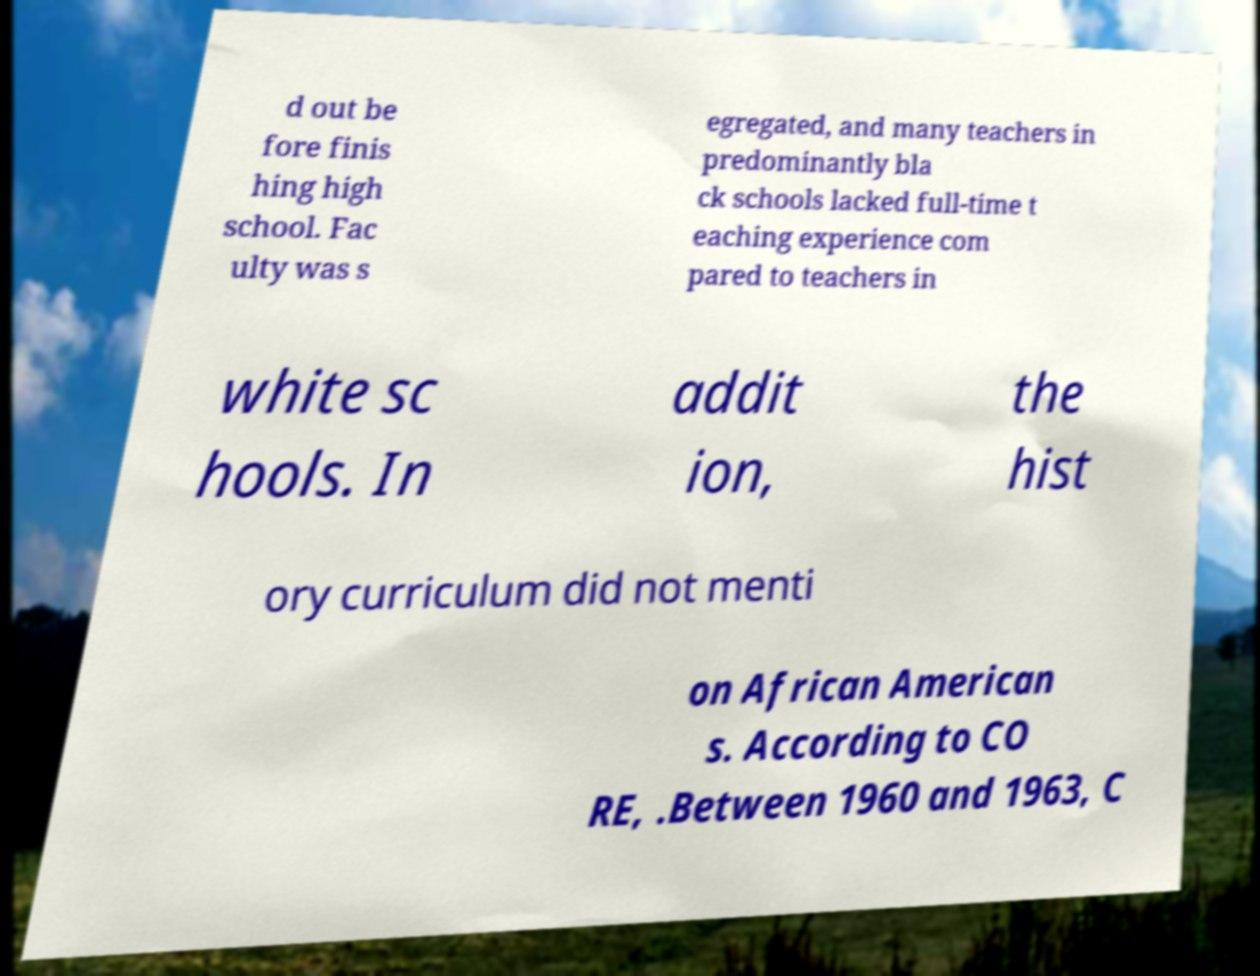Could you extract and type out the text from this image? d out be fore finis hing high school. Fac ulty was s egregated, and many teachers in predominantly bla ck schools lacked full-time t eaching experience com pared to teachers in white sc hools. In addit ion, the hist ory curriculum did not menti on African American s. According to CO RE, .Between 1960 and 1963, C 